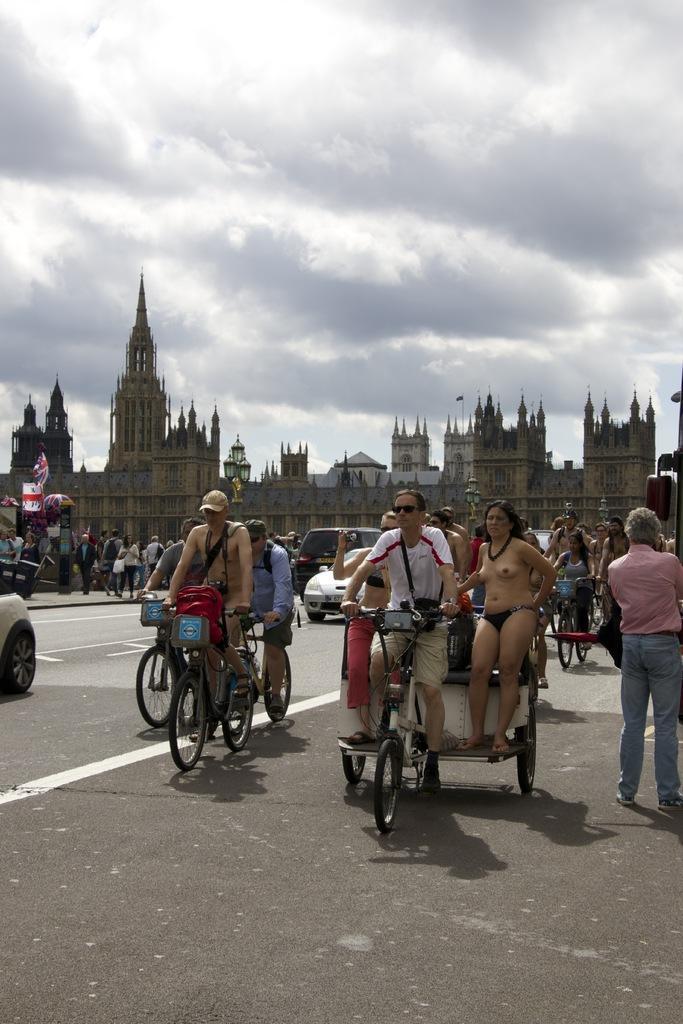Could you give a brief overview of what you see in this image? In this image, we can see people riding on the bicycles and some of them are nude and some are wearing glasses and caps. In the background, there are buildings, flags, vehicles and some people and poles. At the bottom, there is road and at the top, there are clouds in the sky. 